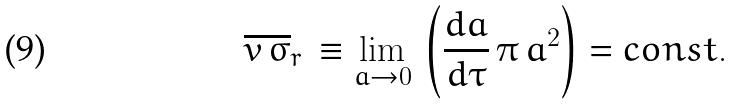<formula> <loc_0><loc_0><loc_500><loc_500>\overline { v \, \sigma } _ { r } \, \equiv \lim _ { a \rightarrow 0 } \, \left ( \frac { d a } { d \tau } \, \pi \, a ^ { 2 } \right ) = c o n s t .</formula> 